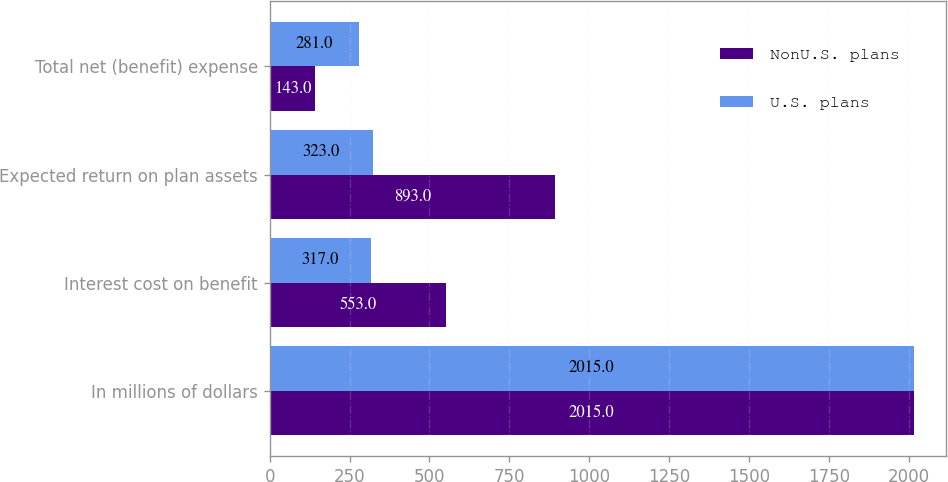Convert chart. <chart><loc_0><loc_0><loc_500><loc_500><stacked_bar_chart><ecel><fcel>In millions of dollars<fcel>Interest cost on benefit<fcel>Expected return on plan assets<fcel>Total net (benefit) expense<nl><fcel>NonU.S. plans<fcel>2015<fcel>553<fcel>893<fcel>143<nl><fcel>U.S. plans<fcel>2015<fcel>317<fcel>323<fcel>281<nl></chart> 